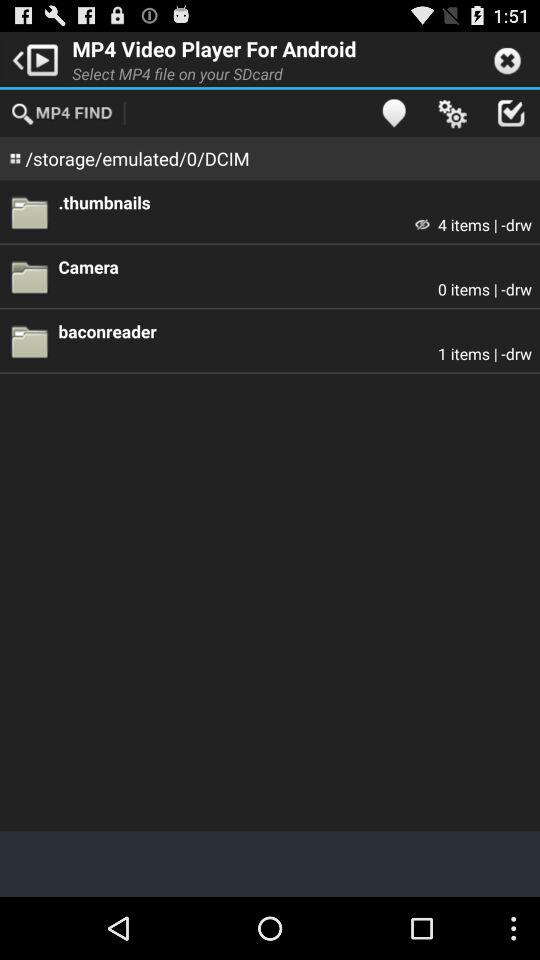How many items are in the ".thumbnails" file? There are 4 items in the ".thumbnails" file. 